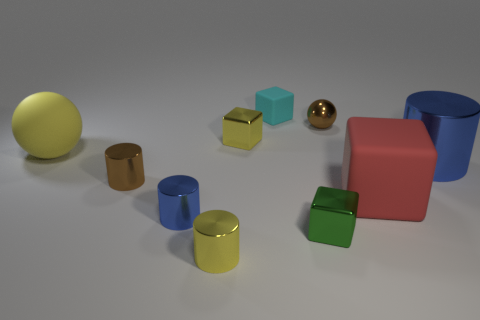How many blue cylinders must be subtracted to get 1 blue cylinders? 1 Subtract 2 cubes. How many cubes are left? 2 Subtract all purple cylinders. Subtract all yellow cubes. How many cylinders are left? 4 Subtract all yellow cylinders. How many yellow balls are left? 1 Subtract all big green balls. Subtract all rubber blocks. How many objects are left? 8 Add 4 small green things. How many small green things are left? 5 Add 6 large yellow objects. How many large yellow objects exist? 7 Subtract all yellow blocks. How many blocks are left? 3 Subtract all large red matte cubes. How many cubes are left? 3 Subtract 1 green cubes. How many objects are left? 9 